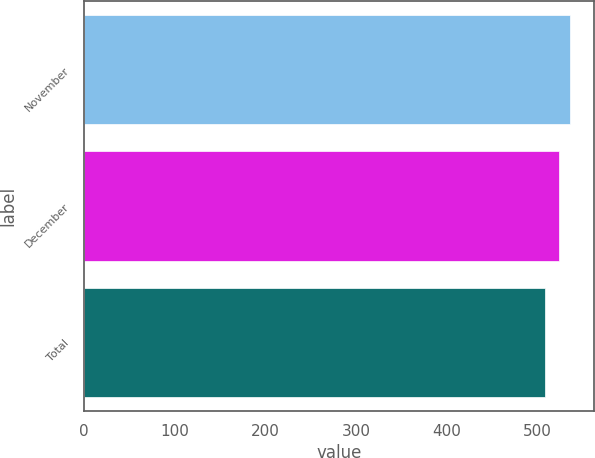Convert chart to OTSL. <chart><loc_0><loc_0><loc_500><loc_500><bar_chart><fcel>November<fcel>December<fcel>Total<nl><fcel>535.45<fcel>523.56<fcel>508.19<nl></chart> 